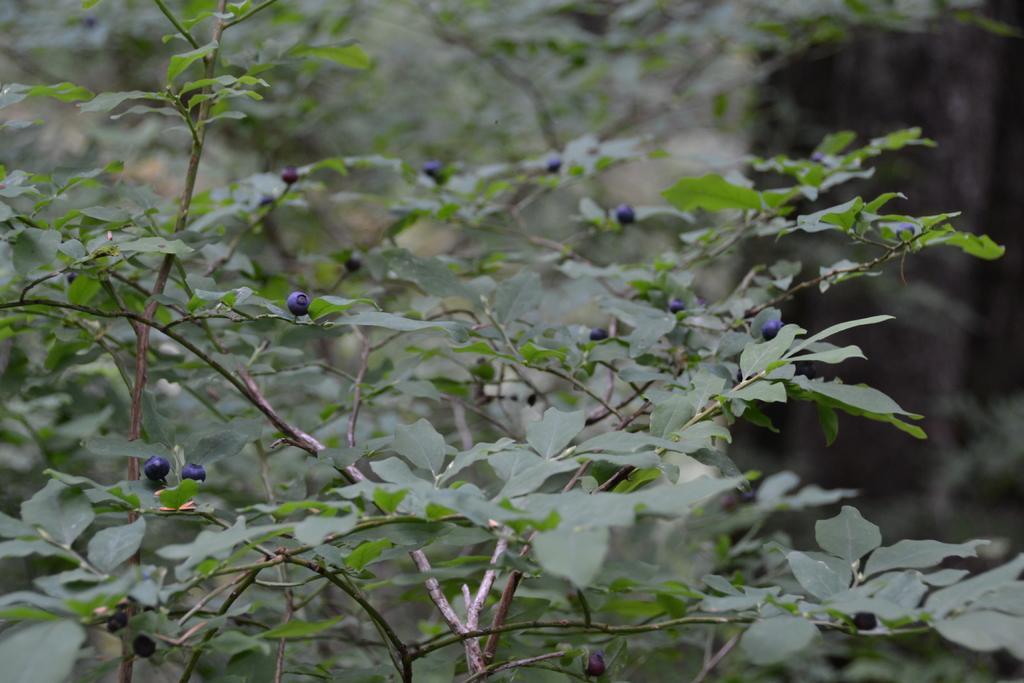Describe this image in one or two sentences. In this image we can see a tree with fruits. The background of the image is slightly blurred. 